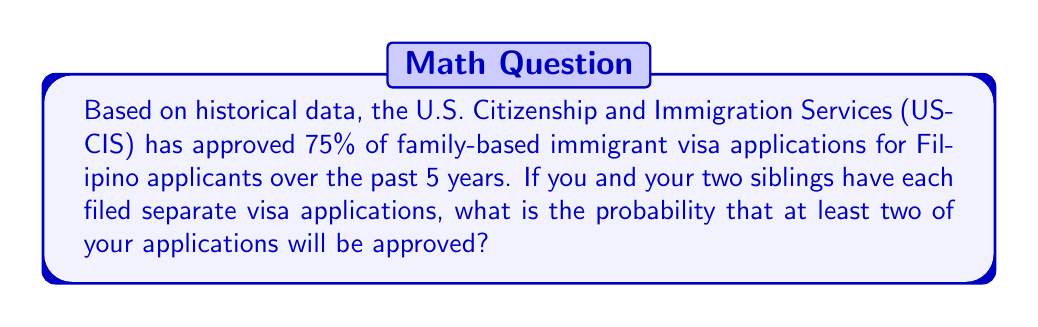Can you solve this math problem? Let's approach this step-by-step:

1) First, we need to identify the probability of a single application being approved:
   $p = 0.75$ (75% = 0.75)

2) The probability of an application being rejected is:
   $q = 1 - p = 1 - 0.75 = 0.25$

3) We want the probability of at least two approvals out of three applications. This can happen in two ways:
   a) All three applications are approved
   b) Exactly two applications are approved

4) Let's calculate the probability of each scenario:
   a) Probability of all three approved: $p^3 = 0.75^3 = 0.421875$
   b) Probability of exactly two approved: $\binom{3}{2} \cdot p^2 \cdot q = 3 \cdot 0.75^2 \cdot 0.25 = 0.421875$

   Where $\binom{3}{2}$ is the binomial coefficient, calculated as:
   $$\binom{3}{2} = \frac{3!}{2!(3-2)!} = \frac{3 \cdot 2 \cdot 1}{(2 \cdot 1)(1)} = 3$$

5) The total probability is the sum of these two scenarios:
   $$P(\text{at least two approved}) = 0.421875 + 0.421875 = 0.84375$$

6) Converting to a percentage: $0.84375 \cdot 100\% = 84.375\%$
Answer: 84.375% 